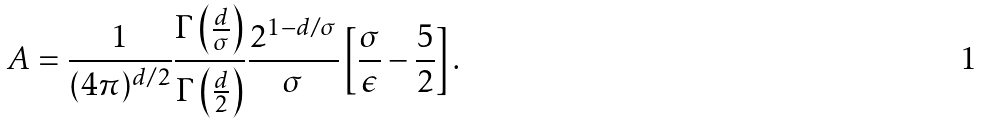Convert formula to latex. <formula><loc_0><loc_0><loc_500><loc_500>A = \frac { 1 } { ( 4 \pi ) ^ { d / 2 } } \frac { \Gamma \left ( \frac { d } { \sigma } \right ) } { { \Gamma \left ( \frac { d } { 2 } \right ) } } \frac { 2 ^ { 1 - d / \sigma } } { \sigma } \left [ \frac { \sigma } { \epsilon } - \frac { 5 } { 2 } \right ] .</formula> 